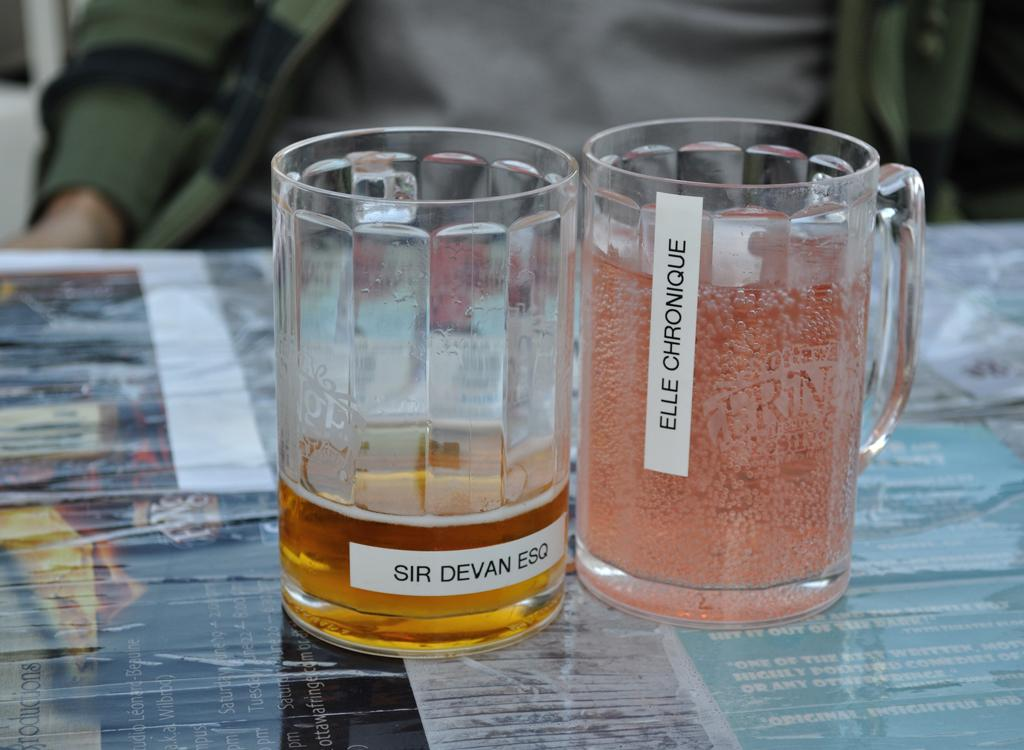<image>
Relay a brief, clear account of the picture shown. Two mugs labeled Sir Devan ESQ and Elle Chronique. 